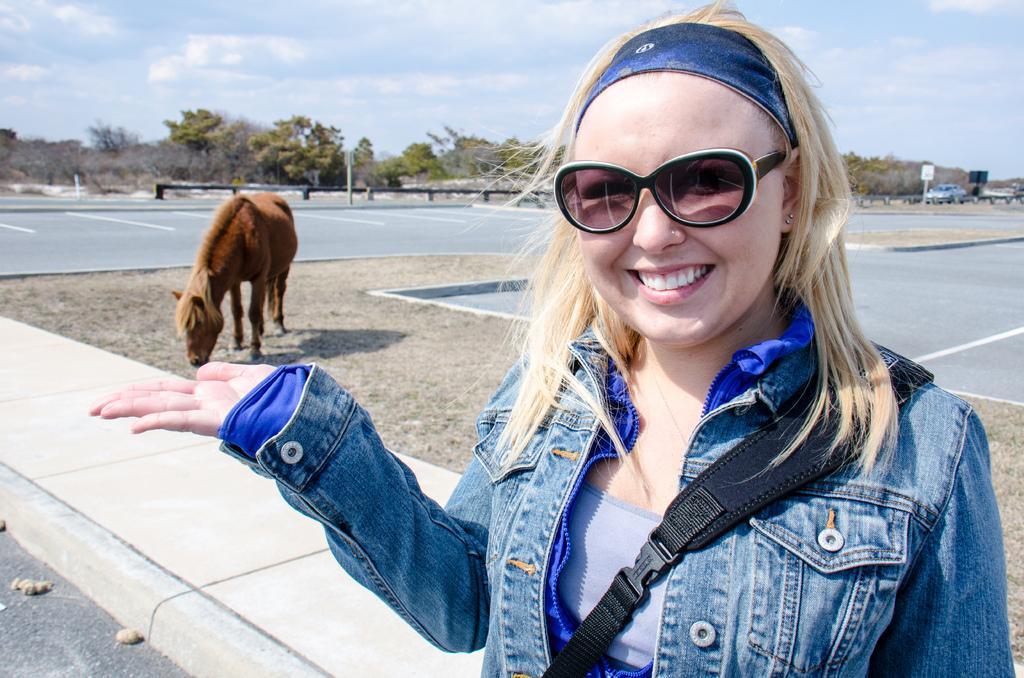Can you describe this image briefly? In this image, we can see a person wearing spectacles. We can also see an animal and a vehicle. We can some poles with boards. We can see the ground with some objects. We can also see the sky with clouds. There are a few trees. 